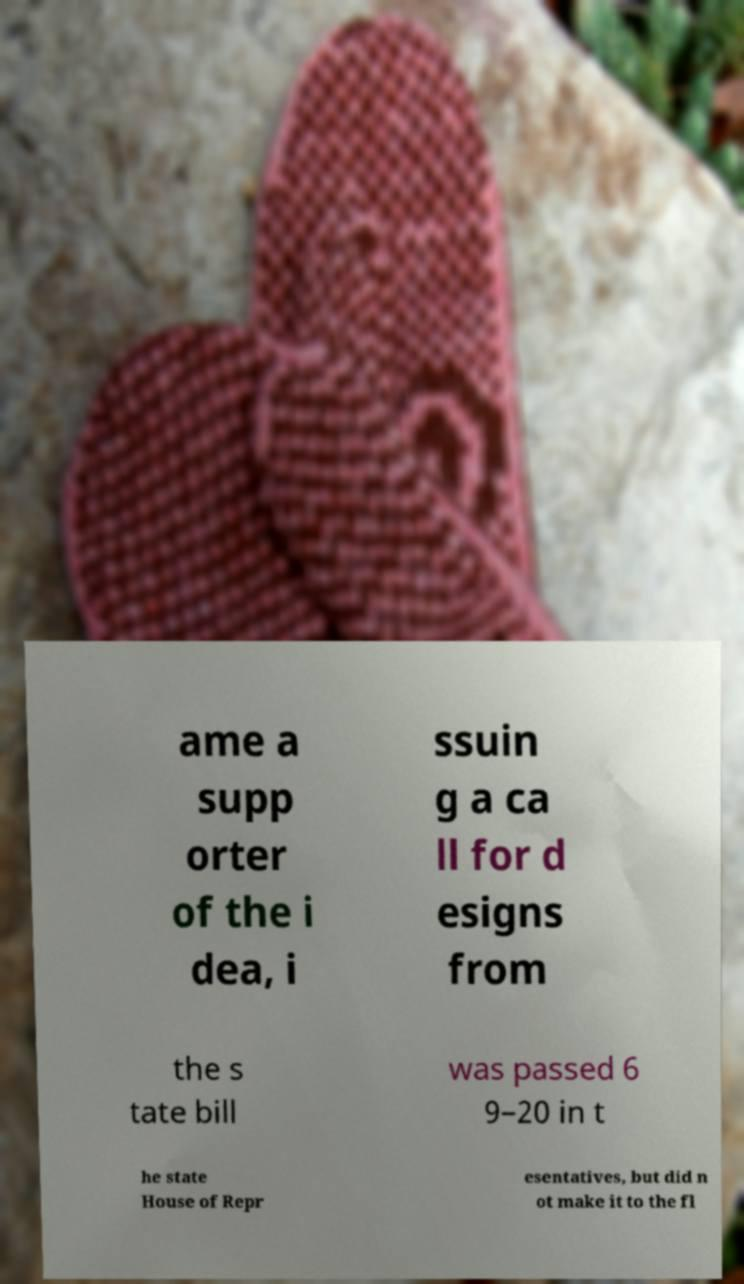Please read and relay the text visible in this image. What does it say? ame a supp orter of the i dea, i ssuin g a ca ll for d esigns from the s tate bill was passed 6 9–20 in t he state House of Repr esentatives, but did n ot make it to the fl 